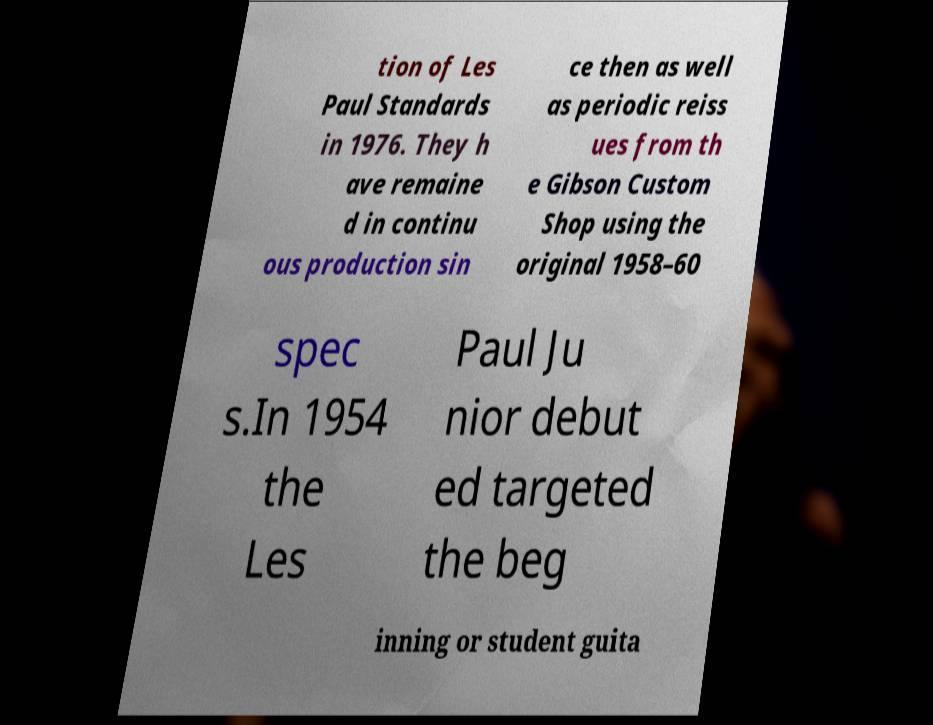Could you assist in decoding the text presented in this image and type it out clearly? tion of Les Paul Standards in 1976. They h ave remaine d in continu ous production sin ce then as well as periodic reiss ues from th e Gibson Custom Shop using the original 1958–60 spec s.In 1954 the Les Paul Ju nior debut ed targeted the beg inning or student guita 